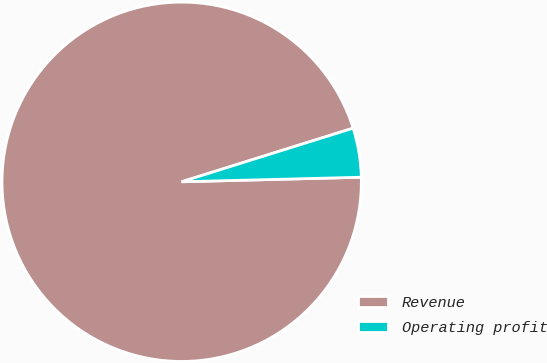<chart> <loc_0><loc_0><loc_500><loc_500><pie_chart><fcel>Revenue<fcel>Operating profit<nl><fcel>95.58%<fcel>4.42%<nl></chart> 